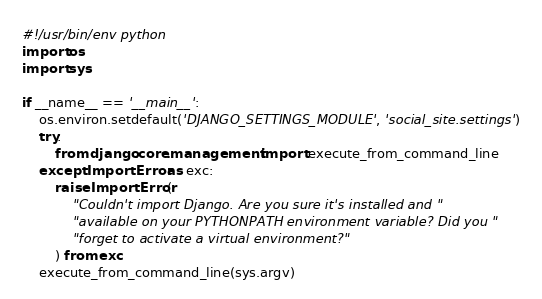Convert code to text. <code><loc_0><loc_0><loc_500><loc_500><_Python_>#!/usr/bin/env python
import os
import sys

if __name__ == '__main__':
    os.environ.setdefault('DJANGO_SETTINGS_MODULE', 'social_site.settings')
    try:
        from django.core.management import execute_from_command_line
    except ImportError as exc:
        raise ImportError(
            "Couldn't import Django. Are you sure it's installed and "
            "available on your PYTHONPATH environment variable? Did you "
            "forget to activate a virtual environment?"
        ) from exc
    execute_from_command_line(sys.argv)
</code> 